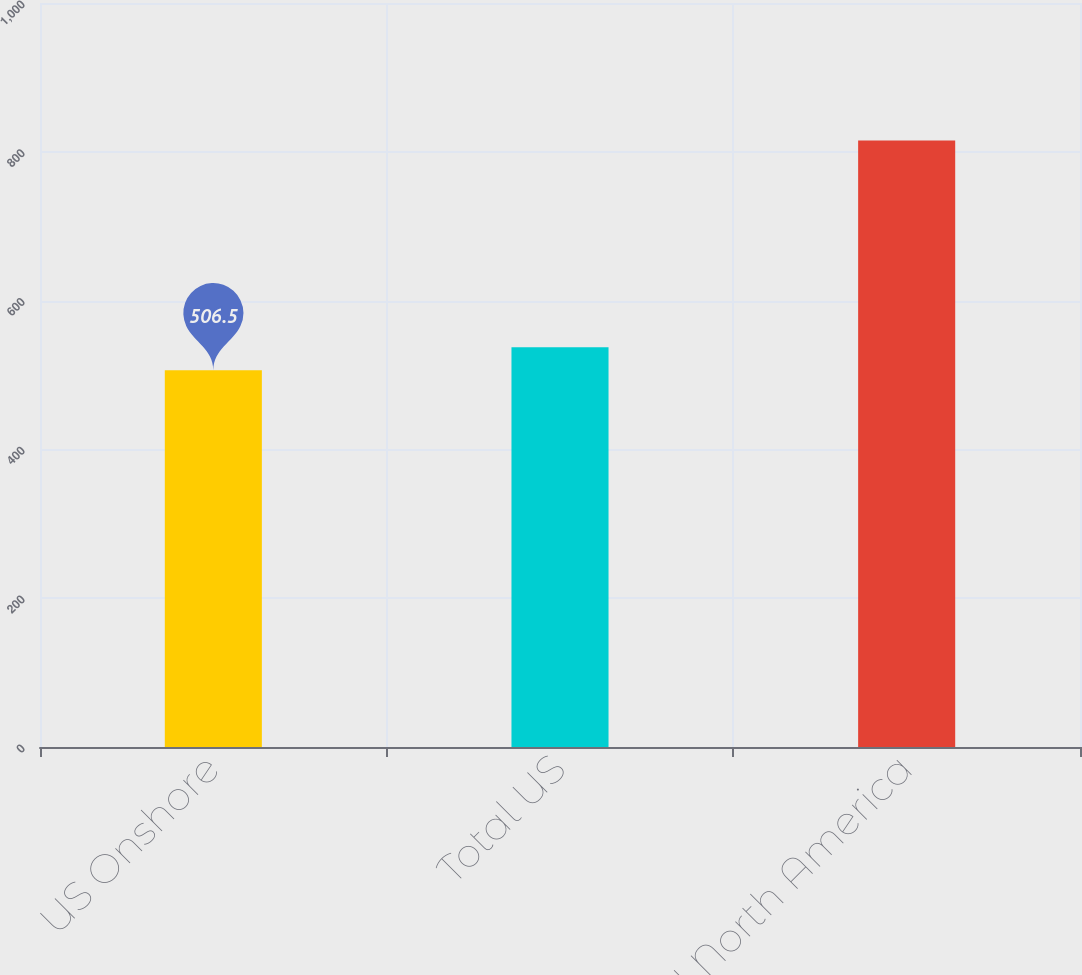Convert chart. <chart><loc_0><loc_0><loc_500><loc_500><bar_chart><fcel>US Onshore<fcel>Total US<fcel>Total North America<nl><fcel>506.5<fcel>537.37<fcel>815.2<nl></chart> 